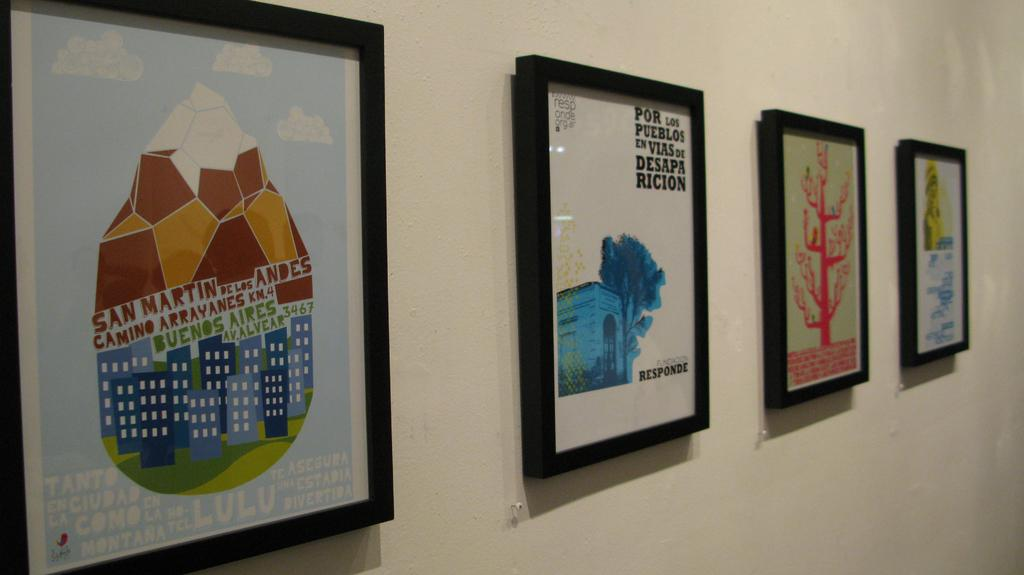<image>
Render a clear and concise summary of the photo. Four framed decors hanging on the wall and one of them has wordings  Por Los pueblos en vias de desapa ricion 